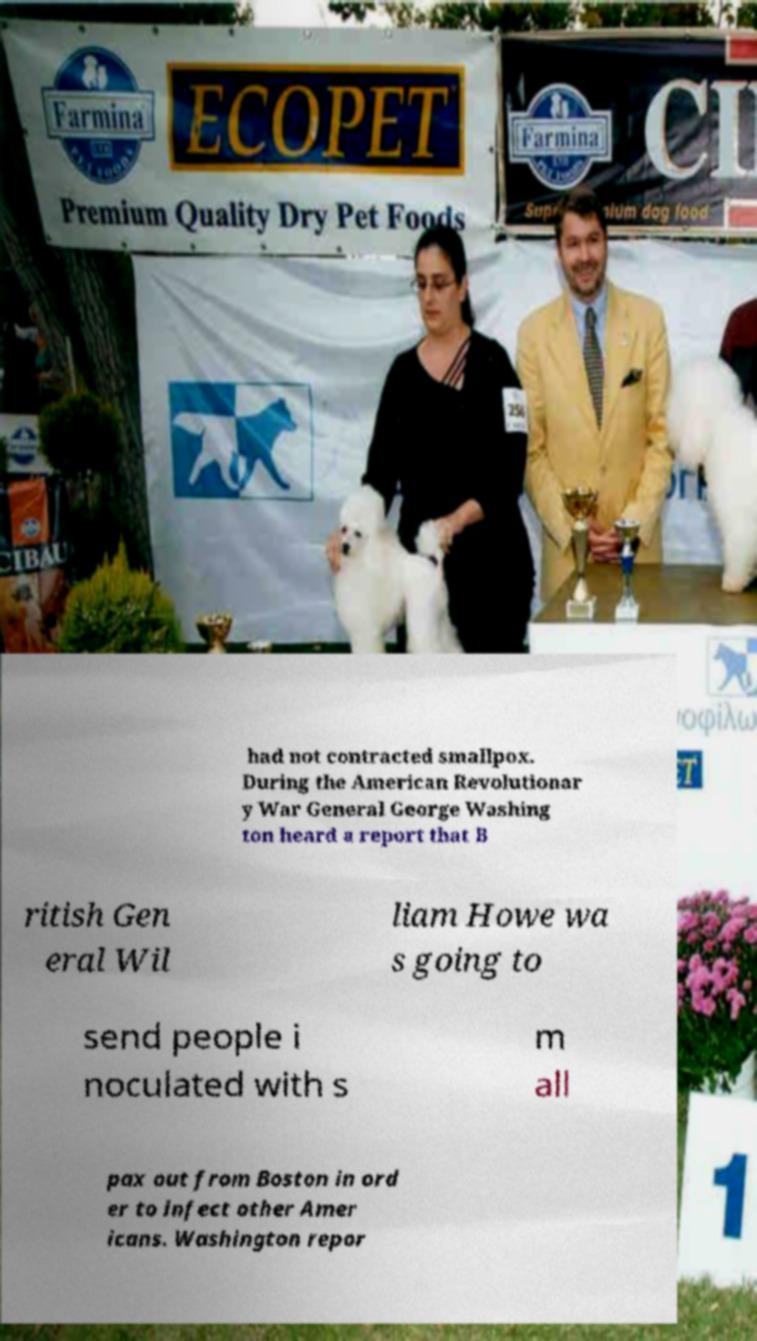For documentation purposes, I need the text within this image transcribed. Could you provide that? had not contracted smallpox. During the American Revolutionar y War General George Washing ton heard a report that B ritish Gen eral Wil liam Howe wa s going to send people i noculated with s m all pax out from Boston in ord er to infect other Amer icans. Washington repor 